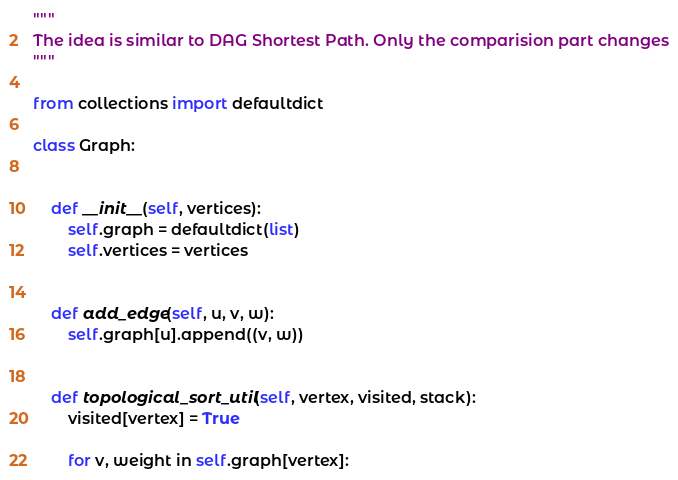Convert code to text. <code><loc_0><loc_0><loc_500><loc_500><_Python_>"""
The idea is similar to DAG Shortest Path. Only the comparision part changes
"""

from collections import defaultdict

class Graph:


    def __init__(self, vertices):
        self.graph = defaultdict(list)
        self.vertices = vertices


    def add_edge(self, u, v, w):
        self.graph[u].append((v, w))


    def topological_sort_util(self, vertex, visited, stack):
        visited[vertex] = True

        for v, weight in self.graph[vertex]:</code> 